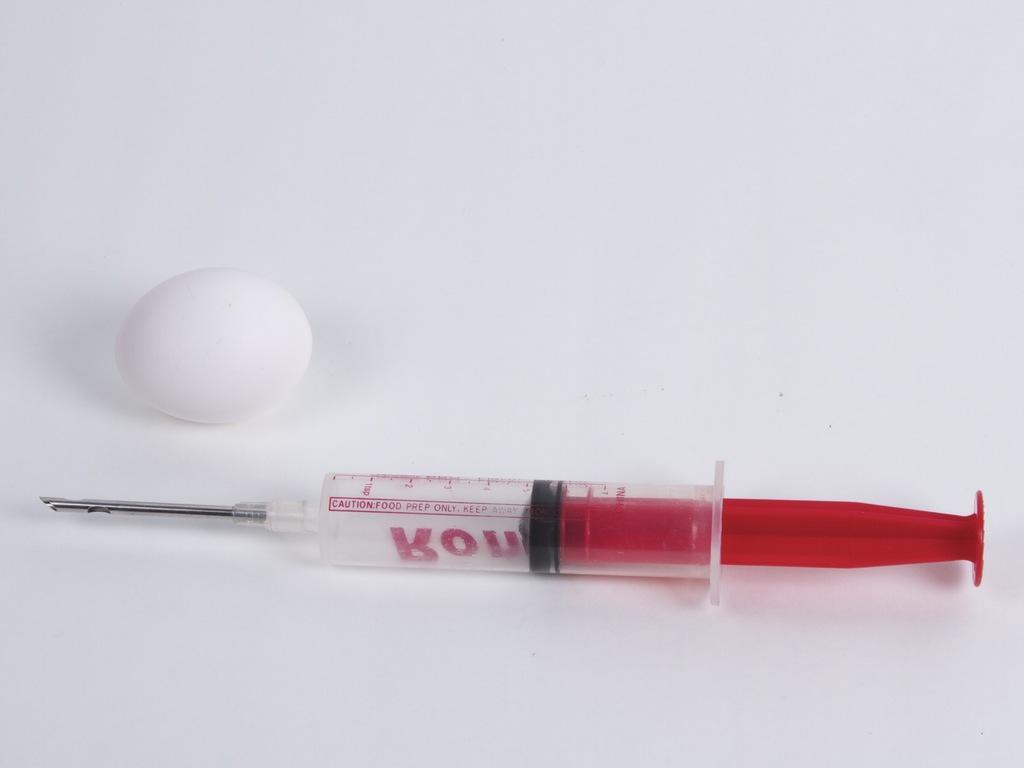Please provide a concise description of this image. In the center of the image there is a syringe. There is a egg. 